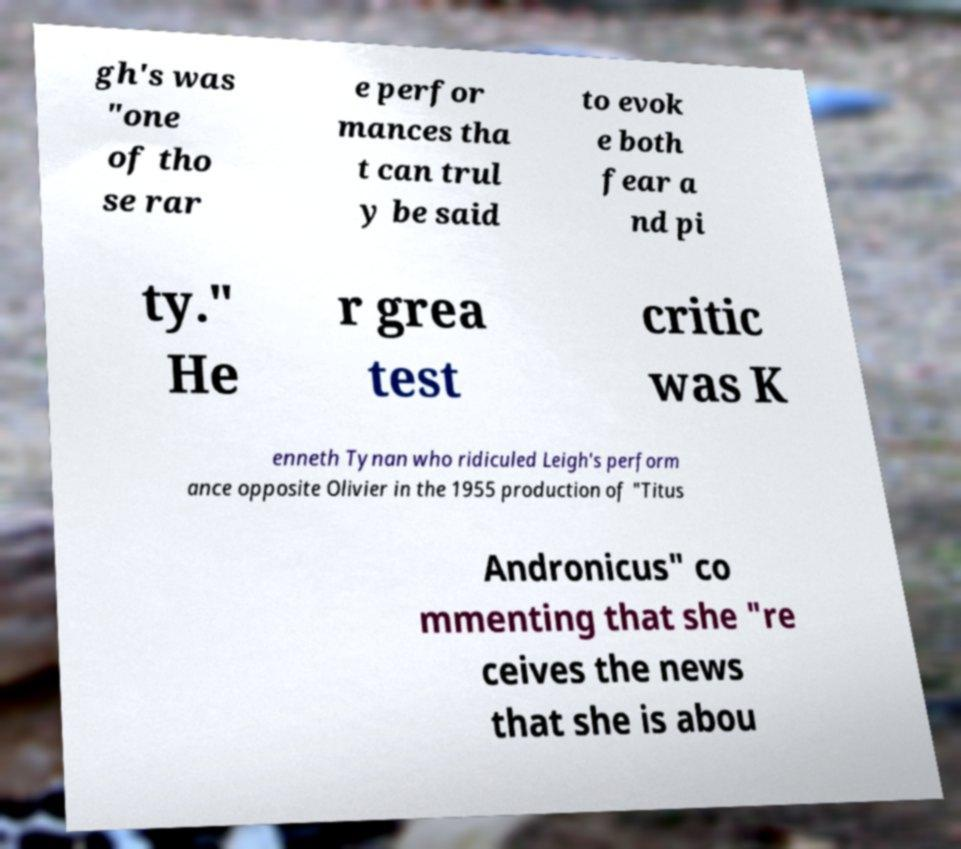Please read and relay the text visible in this image. What does it say? gh's was "one of tho se rar e perfor mances tha t can trul y be said to evok e both fear a nd pi ty." He r grea test critic was K enneth Tynan who ridiculed Leigh's perform ance opposite Olivier in the 1955 production of "Titus Andronicus" co mmenting that she "re ceives the news that she is abou 